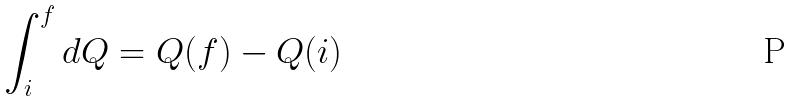Convert formula to latex. <formula><loc_0><loc_0><loc_500><loc_500>\int _ { i } ^ { f } d Q = Q ( f ) - Q ( i )</formula> 